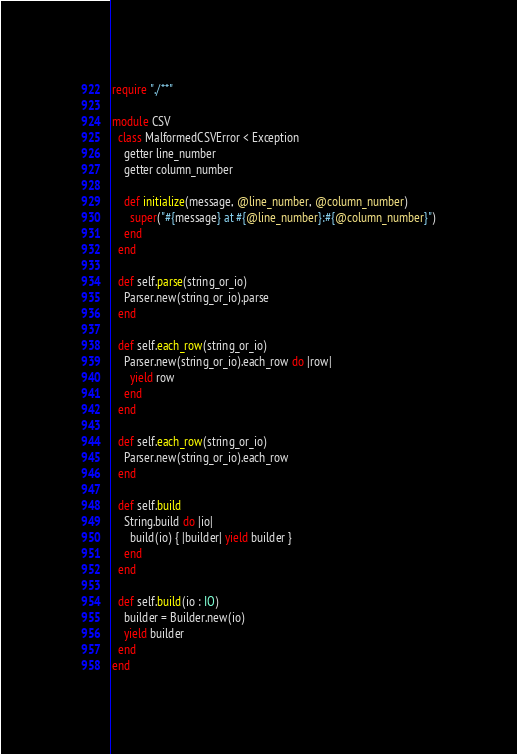<code> <loc_0><loc_0><loc_500><loc_500><_Crystal_>require "./**"

module CSV
  class MalformedCSVError < Exception
    getter line_number
    getter column_number

    def initialize(message, @line_number, @column_number)
      super("#{message} at #{@line_number}:#{@column_number}")
    end
  end

  def self.parse(string_or_io)
    Parser.new(string_or_io).parse
  end

  def self.each_row(string_or_io)
    Parser.new(string_or_io).each_row do |row|
      yield row
    end
  end

  def self.each_row(string_or_io)
    Parser.new(string_or_io).each_row
  end

  def self.build
    String.build do |io|
      build(io) { |builder| yield builder }
    end
  end

  def self.build(io : IO)
    builder = Builder.new(io)
    yield builder
  end
end
</code> 